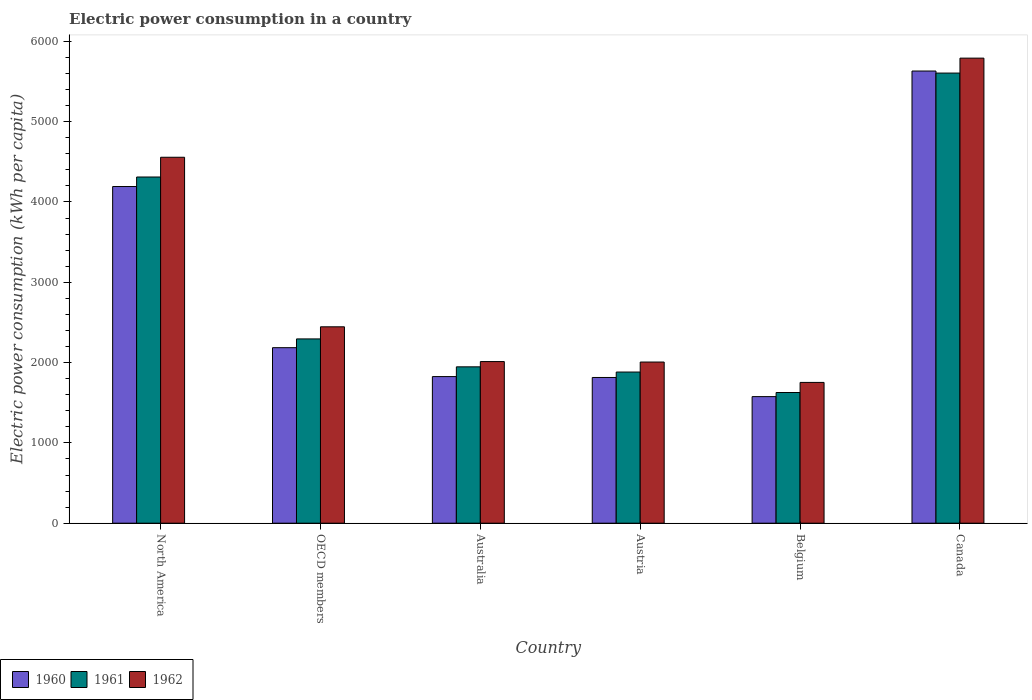How many groups of bars are there?
Offer a very short reply. 6. Are the number of bars per tick equal to the number of legend labels?
Your answer should be compact. Yes. Are the number of bars on each tick of the X-axis equal?
Your response must be concise. Yes. How many bars are there on the 3rd tick from the left?
Offer a terse response. 3. How many bars are there on the 2nd tick from the right?
Offer a terse response. 3. What is the electric power consumption in in 1962 in North America?
Your answer should be compact. 4556.78. Across all countries, what is the maximum electric power consumption in in 1960?
Ensure brevity in your answer.  5630.63. Across all countries, what is the minimum electric power consumption in in 1962?
Make the answer very short. 1753.14. In which country was the electric power consumption in in 1961 minimum?
Provide a succinct answer. Belgium. What is the total electric power consumption in in 1960 in the graph?
Ensure brevity in your answer.  1.72e+04. What is the difference between the electric power consumption in in 1962 in Belgium and that in North America?
Offer a very short reply. -2803.63. What is the difference between the electric power consumption in in 1962 in Austria and the electric power consumption in in 1960 in North America?
Give a very brief answer. -2185.59. What is the average electric power consumption in in 1960 per country?
Your response must be concise. 2870.86. What is the difference between the electric power consumption in of/in 1961 and electric power consumption in of/in 1962 in Belgium?
Make the answer very short. -125.63. In how many countries, is the electric power consumption in in 1961 greater than 1400 kWh per capita?
Offer a terse response. 6. What is the ratio of the electric power consumption in in 1961 in Austria to that in Canada?
Offer a terse response. 0.34. Is the difference between the electric power consumption in in 1961 in Australia and Canada greater than the difference between the electric power consumption in in 1962 in Australia and Canada?
Provide a succinct answer. Yes. What is the difference between the highest and the second highest electric power consumption in in 1962?
Keep it short and to the point. 2111.25. What is the difference between the highest and the lowest electric power consumption in in 1962?
Offer a very short reply. 4037.98. In how many countries, is the electric power consumption in in 1961 greater than the average electric power consumption in in 1961 taken over all countries?
Keep it short and to the point. 2. Is it the case that in every country, the sum of the electric power consumption in in 1962 and electric power consumption in in 1961 is greater than the electric power consumption in in 1960?
Provide a succinct answer. Yes. How many bars are there?
Your response must be concise. 18. Are all the bars in the graph horizontal?
Provide a succinct answer. No. How many countries are there in the graph?
Offer a terse response. 6. Does the graph contain any zero values?
Ensure brevity in your answer.  No. Where does the legend appear in the graph?
Keep it short and to the point. Bottom left. How many legend labels are there?
Your answer should be very brief. 3. What is the title of the graph?
Give a very brief answer. Electric power consumption in a country. What is the label or title of the X-axis?
Provide a succinct answer. Country. What is the label or title of the Y-axis?
Your answer should be very brief. Electric power consumption (kWh per capita). What is the Electric power consumption (kWh per capita) in 1960 in North America?
Keep it short and to the point. 4192.36. What is the Electric power consumption (kWh per capita) in 1961 in North America?
Ensure brevity in your answer.  4310.91. What is the Electric power consumption (kWh per capita) of 1962 in North America?
Offer a very short reply. 4556.78. What is the Electric power consumption (kWh per capita) in 1960 in OECD members?
Your response must be concise. 2185.53. What is the Electric power consumption (kWh per capita) of 1961 in OECD members?
Offer a terse response. 2294.73. What is the Electric power consumption (kWh per capita) of 1962 in OECD members?
Offer a very short reply. 2445.52. What is the Electric power consumption (kWh per capita) of 1960 in Australia?
Make the answer very short. 1825.63. What is the Electric power consumption (kWh per capita) in 1961 in Australia?
Your answer should be very brief. 1947.15. What is the Electric power consumption (kWh per capita) of 1962 in Australia?
Give a very brief answer. 2012.66. What is the Electric power consumption (kWh per capita) in 1960 in Austria?
Your answer should be compact. 1814.68. What is the Electric power consumption (kWh per capita) in 1961 in Austria?
Provide a succinct answer. 1882.22. What is the Electric power consumption (kWh per capita) of 1962 in Austria?
Make the answer very short. 2006.77. What is the Electric power consumption (kWh per capita) of 1960 in Belgium?
Offer a terse response. 1576.34. What is the Electric power consumption (kWh per capita) in 1961 in Belgium?
Provide a succinct answer. 1627.51. What is the Electric power consumption (kWh per capita) of 1962 in Belgium?
Make the answer very short. 1753.14. What is the Electric power consumption (kWh per capita) of 1960 in Canada?
Your response must be concise. 5630.63. What is the Electric power consumption (kWh per capita) of 1961 in Canada?
Provide a short and direct response. 5605.11. What is the Electric power consumption (kWh per capita) in 1962 in Canada?
Ensure brevity in your answer.  5791.12. Across all countries, what is the maximum Electric power consumption (kWh per capita) in 1960?
Give a very brief answer. 5630.63. Across all countries, what is the maximum Electric power consumption (kWh per capita) in 1961?
Your answer should be compact. 5605.11. Across all countries, what is the maximum Electric power consumption (kWh per capita) of 1962?
Make the answer very short. 5791.12. Across all countries, what is the minimum Electric power consumption (kWh per capita) of 1960?
Offer a very short reply. 1576.34. Across all countries, what is the minimum Electric power consumption (kWh per capita) in 1961?
Offer a terse response. 1627.51. Across all countries, what is the minimum Electric power consumption (kWh per capita) of 1962?
Give a very brief answer. 1753.14. What is the total Electric power consumption (kWh per capita) in 1960 in the graph?
Ensure brevity in your answer.  1.72e+04. What is the total Electric power consumption (kWh per capita) in 1961 in the graph?
Keep it short and to the point. 1.77e+04. What is the total Electric power consumption (kWh per capita) in 1962 in the graph?
Your answer should be compact. 1.86e+04. What is the difference between the Electric power consumption (kWh per capita) of 1960 in North America and that in OECD members?
Offer a very short reply. 2006.82. What is the difference between the Electric power consumption (kWh per capita) of 1961 in North America and that in OECD members?
Your answer should be compact. 2016.17. What is the difference between the Electric power consumption (kWh per capita) in 1962 in North America and that in OECD members?
Make the answer very short. 2111.25. What is the difference between the Electric power consumption (kWh per capita) of 1960 in North America and that in Australia?
Offer a very short reply. 2366.73. What is the difference between the Electric power consumption (kWh per capita) in 1961 in North America and that in Australia?
Your response must be concise. 2363.75. What is the difference between the Electric power consumption (kWh per capita) in 1962 in North America and that in Australia?
Provide a succinct answer. 2544.12. What is the difference between the Electric power consumption (kWh per capita) of 1960 in North America and that in Austria?
Ensure brevity in your answer.  2377.68. What is the difference between the Electric power consumption (kWh per capita) of 1961 in North America and that in Austria?
Keep it short and to the point. 2428.68. What is the difference between the Electric power consumption (kWh per capita) in 1962 in North America and that in Austria?
Ensure brevity in your answer.  2550.01. What is the difference between the Electric power consumption (kWh per capita) of 1960 in North America and that in Belgium?
Give a very brief answer. 2616.02. What is the difference between the Electric power consumption (kWh per capita) in 1961 in North America and that in Belgium?
Keep it short and to the point. 2683.39. What is the difference between the Electric power consumption (kWh per capita) of 1962 in North America and that in Belgium?
Your answer should be compact. 2803.63. What is the difference between the Electric power consumption (kWh per capita) of 1960 in North America and that in Canada?
Keep it short and to the point. -1438.27. What is the difference between the Electric power consumption (kWh per capita) of 1961 in North America and that in Canada?
Keep it short and to the point. -1294.21. What is the difference between the Electric power consumption (kWh per capita) in 1962 in North America and that in Canada?
Keep it short and to the point. -1234.35. What is the difference between the Electric power consumption (kWh per capita) in 1960 in OECD members and that in Australia?
Keep it short and to the point. 359.91. What is the difference between the Electric power consumption (kWh per capita) of 1961 in OECD members and that in Australia?
Offer a terse response. 347.58. What is the difference between the Electric power consumption (kWh per capita) of 1962 in OECD members and that in Australia?
Your answer should be compact. 432.86. What is the difference between the Electric power consumption (kWh per capita) of 1960 in OECD members and that in Austria?
Offer a terse response. 370.86. What is the difference between the Electric power consumption (kWh per capita) of 1961 in OECD members and that in Austria?
Your answer should be very brief. 412.51. What is the difference between the Electric power consumption (kWh per capita) in 1962 in OECD members and that in Austria?
Offer a terse response. 438.75. What is the difference between the Electric power consumption (kWh per capita) of 1960 in OECD members and that in Belgium?
Offer a terse response. 609.19. What is the difference between the Electric power consumption (kWh per capita) of 1961 in OECD members and that in Belgium?
Ensure brevity in your answer.  667.22. What is the difference between the Electric power consumption (kWh per capita) of 1962 in OECD members and that in Belgium?
Ensure brevity in your answer.  692.38. What is the difference between the Electric power consumption (kWh per capita) of 1960 in OECD members and that in Canada?
Your answer should be very brief. -3445.1. What is the difference between the Electric power consumption (kWh per capita) in 1961 in OECD members and that in Canada?
Ensure brevity in your answer.  -3310.38. What is the difference between the Electric power consumption (kWh per capita) in 1962 in OECD members and that in Canada?
Make the answer very short. -3345.6. What is the difference between the Electric power consumption (kWh per capita) of 1960 in Australia and that in Austria?
Keep it short and to the point. 10.95. What is the difference between the Electric power consumption (kWh per capita) in 1961 in Australia and that in Austria?
Ensure brevity in your answer.  64.93. What is the difference between the Electric power consumption (kWh per capita) in 1962 in Australia and that in Austria?
Make the answer very short. 5.89. What is the difference between the Electric power consumption (kWh per capita) of 1960 in Australia and that in Belgium?
Your answer should be very brief. 249.29. What is the difference between the Electric power consumption (kWh per capita) of 1961 in Australia and that in Belgium?
Offer a very short reply. 319.64. What is the difference between the Electric power consumption (kWh per capita) of 1962 in Australia and that in Belgium?
Give a very brief answer. 259.52. What is the difference between the Electric power consumption (kWh per capita) in 1960 in Australia and that in Canada?
Provide a short and direct response. -3805. What is the difference between the Electric power consumption (kWh per capita) of 1961 in Australia and that in Canada?
Provide a short and direct response. -3657.96. What is the difference between the Electric power consumption (kWh per capita) in 1962 in Australia and that in Canada?
Ensure brevity in your answer.  -3778.46. What is the difference between the Electric power consumption (kWh per capita) of 1960 in Austria and that in Belgium?
Give a very brief answer. 238.34. What is the difference between the Electric power consumption (kWh per capita) of 1961 in Austria and that in Belgium?
Your answer should be compact. 254.71. What is the difference between the Electric power consumption (kWh per capita) of 1962 in Austria and that in Belgium?
Offer a very short reply. 253.63. What is the difference between the Electric power consumption (kWh per capita) in 1960 in Austria and that in Canada?
Give a very brief answer. -3815.95. What is the difference between the Electric power consumption (kWh per capita) of 1961 in Austria and that in Canada?
Ensure brevity in your answer.  -3722.89. What is the difference between the Electric power consumption (kWh per capita) of 1962 in Austria and that in Canada?
Offer a very short reply. -3784.35. What is the difference between the Electric power consumption (kWh per capita) of 1960 in Belgium and that in Canada?
Offer a very short reply. -4054.29. What is the difference between the Electric power consumption (kWh per capita) of 1961 in Belgium and that in Canada?
Keep it short and to the point. -3977.6. What is the difference between the Electric power consumption (kWh per capita) of 1962 in Belgium and that in Canada?
Your response must be concise. -4037.98. What is the difference between the Electric power consumption (kWh per capita) in 1960 in North America and the Electric power consumption (kWh per capita) in 1961 in OECD members?
Give a very brief answer. 1897.62. What is the difference between the Electric power consumption (kWh per capita) of 1960 in North America and the Electric power consumption (kWh per capita) of 1962 in OECD members?
Your answer should be very brief. 1746.83. What is the difference between the Electric power consumption (kWh per capita) in 1961 in North America and the Electric power consumption (kWh per capita) in 1962 in OECD members?
Your answer should be very brief. 1865.38. What is the difference between the Electric power consumption (kWh per capita) of 1960 in North America and the Electric power consumption (kWh per capita) of 1961 in Australia?
Your answer should be very brief. 2245.2. What is the difference between the Electric power consumption (kWh per capita) in 1960 in North America and the Electric power consumption (kWh per capita) in 1962 in Australia?
Your answer should be compact. 2179.7. What is the difference between the Electric power consumption (kWh per capita) of 1961 in North America and the Electric power consumption (kWh per capita) of 1962 in Australia?
Give a very brief answer. 2298.24. What is the difference between the Electric power consumption (kWh per capita) of 1960 in North America and the Electric power consumption (kWh per capita) of 1961 in Austria?
Keep it short and to the point. 2310.13. What is the difference between the Electric power consumption (kWh per capita) in 1960 in North America and the Electric power consumption (kWh per capita) in 1962 in Austria?
Offer a terse response. 2185.59. What is the difference between the Electric power consumption (kWh per capita) of 1961 in North America and the Electric power consumption (kWh per capita) of 1962 in Austria?
Your response must be concise. 2304.13. What is the difference between the Electric power consumption (kWh per capita) of 1960 in North America and the Electric power consumption (kWh per capita) of 1961 in Belgium?
Provide a succinct answer. 2564.84. What is the difference between the Electric power consumption (kWh per capita) in 1960 in North America and the Electric power consumption (kWh per capita) in 1962 in Belgium?
Give a very brief answer. 2439.21. What is the difference between the Electric power consumption (kWh per capita) of 1961 in North America and the Electric power consumption (kWh per capita) of 1962 in Belgium?
Your answer should be very brief. 2557.76. What is the difference between the Electric power consumption (kWh per capita) in 1960 in North America and the Electric power consumption (kWh per capita) in 1961 in Canada?
Keep it short and to the point. -1412.76. What is the difference between the Electric power consumption (kWh per capita) in 1960 in North America and the Electric power consumption (kWh per capita) in 1962 in Canada?
Ensure brevity in your answer.  -1598.77. What is the difference between the Electric power consumption (kWh per capita) of 1961 in North America and the Electric power consumption (kWh per capita) of 1962 in Canada?
Make the answer very short. -1480.22. What is the difference between the Electric power consumption (kWh per capita) of 1960 in OECD members and the Electric power consumption (kWh per capita) of 1961 in Australia?
Your answer should be very brief. 238.38. What is the difference between the Electric power consumption (kWh per capita) in 1960 in OECD members and the Electric power consumption (kWh per capita) in 1962 in Australia?
Provide a short and direct response. 172.87. What is the difference between the Electric power consumption (kWh per capita) of 1961 in OECD members and the Electric power consumption (kWh per capita) of 1962 in Australia?
Give a very brief answer. 282.07. What is the difference between the Electric power consumption (kWh per capita) of 1960 in OECD members and the Electric power consumption (kWh per capita) of 1961 in Austria?
Your answer should be compact. 303.31. What is the difference between the Electric power consumption (kWh per capita) in 1960 in OECD members and the Electric power consumption (kWh per capita) in 1962 in Austria?
Ensure brevity in your answer.  178.76. What is the difference between the Electric power consumption (kWh per capita) of 1961 in OECD members and the Electric power consumption (kWh per capita) of 1962 in Austria?
Offer a very short reply. 287.96. What is the difference between the Electric power consumption (kWh per capita) in 1960 in OECD members and the Electric power consumption (kWh per capita) in 1961 in Belgium?
Make the answer very short. 558.02. What is the difference between the Electric power consumption (kWh per capita) of 1960 in OECD members and the Electric power consumption (kWh per capita) of 1962 in Belgium?
Make the answer very short. 432.39. What is the difference between the Electric power consumption (kWh per capita) of 1961 in OECD members and the Electric power consumption (kWh per capita) of 1962 in Belgium?
Offer a terse response. 541.59. What is the difference between the Electric power consumption (kWh per capita) of 1960 in OECD members and the Electric power consumption (kWh per capita) of 1961 in Canada?
Your response must be concise. -3419.58. What is the difference between the Electric power consumption (kWh per capita) of 1960 in OECD members and the Electric power consumption (kWh per capita) of 1962 in Canada?
Your answer should be compact. -3605.59. What is the difference between the Electric power consumption (kWh per capita) in 1961 in OECD members and the Electric power consumption (kWh per capita) in 1962 in Canada?
Make the answer very short. -3496.39. What is the difference between the Electric power consumption (kWh per capita) in 1960 in Australia and the Electric power consumption (kWh per capita) in 1961 in Austria?
Keep it short and to the point. -56.6. What is the difference between the Electric power consumption (kWh per capita) of 1960 in Australia and the Electric power consumption (kWh per capita) of 1962 in Austria?
Give a very brief answer. -181.14. What is the difference between the Electric power consumption (kWh per capita) in 1961 in Australia and the Electric power consumption (kWh per capita) in 1962 in Austria?
Your answer should be very brief. -59.62. What is the difference between the Electric power consumption (kWh per capita) in 1960 in Australia and the Electric power consumption (kWh per capita) in 1961 in Belgium?
Make the answer very short. 198.11. What is the difference between the Electric power consumption (kWh per capita) of 1960 in Australia and the Electric power consumption (kWh per capita) of 1962 in Belgium?
Your response must be concise. 72.48. What is the difference between the Electric power consumption (kWh per capita) of 1961 in Australia and the Electric power consumption (kWh per capita) of 1962 in Belgium?
Keep it short and to the point. 194.01. What is the difference between the Electric power consumption (kWh per capita) of 1960 in Australia and the Electric power consumption (kWh per capita) of 1961 in Canada?
Your answer should be very brief. -3779.49. What is the difference between the Electric power consumption (kWh per capita) of 1960 in Australia and the Electric power consumption (kWh per capita) of 1962 in Canada?
Your answer should be compact. -3965.5. What is the difference between the Electric power consumption (kWh per capita) in 1961 in Australia and the Electric power consumption (kWh per capita) in 1962 in Canada?
Offer a very short reply. -3843.97. What is the difference between the Electric power consumption (kWh per capita) of 1960 in Austria and the Electric power consumption (kWh per capita) of 1961 in Belgium?
Offer a very short reply. 187.16. What is the difference between the Electric power consumption (kWh per capita) of 1960 in Austria and the Electric power consumption (kWh per capita) of 1962 in Belgium?
Your answer should be compact. 61.53. What is the difference between the Electric power consumption (kWh per capita) of 1961 in Austria and the Electric power consumption (kWh per capita) of 1962 in Belgium?
Make the answer very short. 129.08. What is the difference between the Electric power consumption (kWh per capita) in 1960 in Austria and the Electric power consumption (kWh per capita) in 1961 in Canada?
Give a very brief answer. -3790.44. What is the difference between the Electric power consumption (kWh per capita) in 1960 in Austria and the Electric power consumption (kWh per capita) in 1962 in Canada?
Your answer should be very brief. -3976.45. What is the difference between the Electric power consumption (kWh per capita) in 1961 in Austria and the Electric power consumption (kWh per capita) in 1962 in Canada?
Your response must be concise. -3908.9. What is the difference between the Electric power consumption (kWh per capita) in 1960 in Belgium and the Electric power consumption (kWh per capita) in 1961 in Canada?
Ensure brevity in your answer.  -4028.77. What is the difference between the Electric power consumption (kWh per capita) of 1960 in Belgium and the Electric power consumption (kWh per capita) of 1962 in Canada?
Offer a terse response. -4214.79. What is the difference between the Electric power consumption (kWh per capita) in 1961 in Belgium and the Electric power consumption (kWh per capita) in 1962 in Canada?
Provide a short and direct response. -4163.61. What is the average Electric power consumption (kWh per capita) in 1960 per country?
Ensure brevity in your answer.  2870.86. What is the average Electric power consumption (kWh per capita) in 1961 per country?
Offer a very short reply. 2944.61. What is the average Electric power consumption (kWh per capita) of 1962 per country?
Your answer should be compact. 3094.33. What is the difference between the Electric power consumption (kWh per capita) in 1960 and Electric power consumption (kWh per capita) in 1961 in North America?
Ensure brevity in your answer.  -118.55. What is the difference between the Electric power consumption (kWh per capita) of 1960 and Electric power consumption (kWh per capita) of 1962 in North America?
Make the answer very short. -364.42. What is the difference between the Electric power consumption (kWh per capita) in 1961 and Electric power consumption (kWh per capita) in 1962 in North America?
Offer a very short reply. -245.87. What is the difference between the Electric power consumption (kWh per capita) of 1960 and Electric power consumption (kWh per capita) of 1961 in OECD members?
Make the answer very short. -109.2. What is the difference between the Electric power consumption (kWh per capita) in 1960 and Electric power consumption (kWh per capita) in 1962 in OECD members?
Your response must be concise. -259.99. What is the difference between the Electric power consumption (kWh per capita) in 1961 and Electric power consumption (kWh per capita) in 1962 in OECD members?
Give a very brief answer. -150.79. What is the difference between the Electric power consumption (kWh per capita) in 1960 and Electric power consumption (kWh per capita) in 1961 in Australia?
Make the answer very short. -121.53. What is the difference between the Electric power consumption (kWh per capita) of 1960 and Electric power consumption (kWh per capita) of 1962 in Australia?
Make the answer very short. -187.03. What is the difference between the Electric power consumption (kWh per capita) of 1961 and Electric power consumption (kWh per capita) of 1962 in Australia?
Offer a very short reply. -65.51. What is the difference between the Electric power consumption (kWh per capita) in 1960 and Electric power consumption (kWh per capita) in 1961 in Austria?
Your answer should be very brief. -67.55. What is the difference between the Electric power consumption (kWh per capita) of 1960 and Electric power consumption (kWh per capita) of 1962 in Austria?
Provide a short and direct response. -192.09. What is the difference between the Electric power consumption (kWh per capita) of 1961 and Electric power consumption (kWh per capita) of 1962 in Austria?
Offer a very short reply. -124.55. What is the difference between the Electric power consumption (kWh per capita) of 1960 and Electric power consumption (kWh per capita) of 1961 in Belgium?
Offer a very short reply. -51.17. What is the difference between the Electric power consumption (kWh per capita) of 1960 and Electric power consumption (kWh per capita) of 1962 in Belgium?
Keep it short and to the point. -176.81. What is the difference between the Electric power consumption (kWh per capita) in 1961 and Electric power consumption (kWh per capita) in 1962 in Belgium?
Ensure brevity in your answer.  -125.63. What is the difference between the Electric power consumption (kWh per capita) of 1960 and Electric power consumption (kWh per capita) of 1961 in Canada?
Your answer should be very brief. 25.52. What is the difference between the Electric power consumption (kWh per capita) of 1960 and Electric power consumption (kWh per capita) of 1962 in Canada?
Provide a short and direct response. -160.5. What is the difference between the Electric power consumption (kWh per capita) in 1961 and Electric power consumption (kWh per capita) in 1962 in Canada?
Give a very brief answer. -186.01. What is the ratio of the Electric power consumption (kWh per capita) of 1960 in North America to that in OECD members?
Ensure brevity in your answer.  1.92. What is the ratio of the Electric power consumption (kWh per capita) in 1961 in North America to that in OECD members?
Make the answer very short. 1.88. What is the ratio of the Electric power consumption (kWh per capita) in 1962 in North America to that in OECD members?
Your response must be concise. 1.86. What is the ratio of the Electric power consumption (kWh per capita) of 1960 in North America to that in Australia?
Give a very brief answer. 2.3. What is the ratio of the Electric power consumption (kWh per capita) of 1961 in North America to that in Australia?
Provide a succinct answer. 2.21. What is the ratio of the Electric power consumption (kWh per capita) in 1962 in North America to that in Australia?
Keep it short and to the point. 2.26. What is the ratio of the Electric power consumption (kWh per capita) in 1960 in North America to that in Austria?
Give a very brief answer. 2.31. What is the ratio of the Electric power consumption (kWh per capita) of 1961 in North America to that in Austria?
Ensure brevity in your answer.  2.29. What is the ratio of the Electric power consumption (kWh per capita) in 1962 in North America to that in Austria?
Provide a short and direct response. 2.27. What is the ratio of the Electric power consumption (kWh per capita) of 1960 in North America to that in Belgium?
Your response must be concise. 2.66. What is the ratio of the Electric power consumption (kWh per capita) of 1961 in North America to that in Belgium?
Your answer should be compact. 2.65. What is the ratio of the Electric power consumption (kWh per capita) of 1962 in North America to that in Belgium?
Your answer should be very brief. 2.6. What is the ratio of the Electric power consumption (kWh per capita) of 1960 in North America to that in Canada?
Provide a short and direct response. 0.74. What is the ratio of the Electric power consumption (kWh per capita) in 1961 in North America to that in Canada?
Make the answer very short. 0.77. What is the ratio of the Electric power consumption (kWh per capita) in 1962 in North America to that in Canada?
Give a very brief answer. 0.79. What is the ratio of the Electric power consumption (kWh per capita) of 1960 in OECD members to that in Australia?
Provide a succinct answer. 1.2. What is the ratio of the Electric power consumption (kWh per capita) in 1961 in OECD members to that in Australia?
Provide a succinct answer. 1.18. What is the ratio of the Electric power consumption (kWh per capita) in 1962 in OECD members to that in Australia?
Offer a very short reply. 1.22. What is the ratio of the Electric power consumption (kWh per capita) in 1960 in OECD members to that in Austria?
Your answer should be very brief. 1.2. What is the ratio of the Electric power consumption (kWh per capita) of 1961 in OECD members to that in Austria?
Give a very brief answer. 1.22. What is the ratio of the Electric power consumption (kWh per capita) of 1962 in OECD members to that in Austria?
Your answer should be very brief. 1.22. What is the ratio of the Electric power consumption (kWh per capita) of 1960 in OECD members to that in Belgium?
Your answer should be very brief. 1.39. What is the ratio of the Electric power consumption (kWh per capita) of 1961 in OECD members to that in Belgium?
Your answer should be compact. 1.41. What is the ratio of the Electric power consumption (kWh per capita) of 1962 in OECD members to that in Belgium?
Provide a short and direct response. 1.39. What is the ratio of the Electric power consumption (kWh per capita) of 1960 in OECD members to that in Canada?
Provide a succinct answer. 0.39. What is the ratio of the Electric power consumption (kWh per capita) in 1961 in OECD members to that in Canada?
Your response must be concise. 0.41. What is the ratio of the Electric power consumption (kWh per capita) in 1962 in OECD members to that in Canada?
Your response must be concise. 0.42. What is the ratio of the Electric power consumption (kWh per capita) in 1961 in Australia to that in Austria?
Give a very brief answer. 1.03. What is the ratio of the Electric power consumption (kWh per capita) of 1962 in Australia to that in Austria?
Make the answer very short. 1. What is the ratio of the Electric power consumption (kWh per capita) of 1960 in Australia to that in Belgium?
Ensure brevity in your answer.  1.16. What is the ratio of the Electric power consumption (kWh per capita) in 1961 in Australia to that in Belgium?
Provide a succinct answer. 1.2. What is the ratio of the Electric power consumption (kWh per capita) of 1962 in Australia to that in Belgium?
Give a very brief answer. 1.15. What is the ratio of the Electric power consumption (kWh per capita) of 1960 in Australia to that in Canada?
Your answer should be very brief. 0.32. What is the ratio of the Electric power consumption (kWh per capita) of 1961 in Australia to that in Canada?
Give a very brief answer. 0.35. What is the ratio of the Electric power consumption (kWh per capita) in 1962 in Australia to that in Canada?
Your response must be concise. 0.35. What is the ratio of the Electric power consumption (kWh per capita) of 1960 in Austria to that in Belgium?
Offer a very short reply. 1.15. What is the ratio of the Electric power consumption (kWh per capita) of 1961 in Austria to that in Belgium?
Offer a terse response. 1.16. What is the ratio of the Electric power consumption (kWh per capita) of 1962 in Austria to that in Belgium?
Provide a short and direct response. 1.14. What is the ratio of the Electric power consumption (kWh per capita) in 1960 in Austria to that in Canada?
Your answer should be compact. 0.32. What is the ratio of the Electric power consumption (kWh per capita) of 1961 in Austria to that in Canada?
Make the answer very short. 0.34. What is the ratio of the Electric power consumption (kWh per capita) of 1962 in Austria to that in Canada?
Offer a very short reply. 0.35. What is the ratio of the Electric power consumption (kWh per capita) in 1960 in Belgium to that in Canada?
Provide a short and direct response. 0.28. What is the ratio of the Electric power consumption (kWh per capita) in 1961 in Belgium to that in Canada?
Provide a succinct answer. 0.29. What is the ratio of the Electric power consumption (kWh per capita) in 1962 in Belgium to that in Canada?
Provide a short and direct response. 0.3. What is the difference between the highest and the second highest Electric power consumption (kWh per capita) of 1960?
Make the answer very short. 1438.27. What is the difference between the highest and the second highest Electric power consumption (kWh per capita) of 1961?
Give a very brief answer. 1294.21. What is the difference between the highest and the second highest Electric power consumption (kWh per capita) of 1962?
Offer a terse response. 1234.35. What is the difference between the highest and the lowest Electric power consumption (kWh per capita) in 1960?
Your response must be concise. 4054.29. What is the difference between the highest and the lowest Electric power consumption (kWh per capita) in 1961?
Make the answer very short. 3977.6. What is the difference between the highest and the lowest Electric power consumption (kWh per capita) of 1962?
Your response must be concise. 4037.98. 